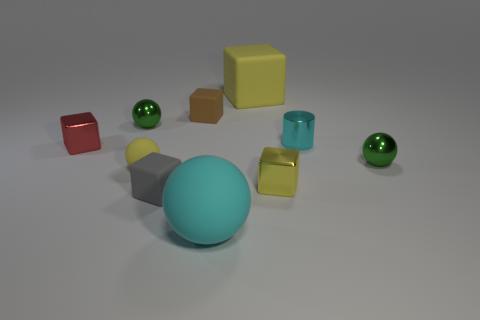What number of things are big yellow balls or yellow blocks?
Give a very brief answer. 2. Is the cyan rubber object the same shape as the small brown thing?
Offer a terse response. No. Is there anything else that is made of the same material as the tiny gray block?
Provide a succinct answer. Yes. Do the green metal ball that is right of the tiny brown matte thing and the yellow ball that is left of the cyan ball have the same size?
Ensure brevity in your answer.  Yes. There is a yellow thing that is right of the big rubber ball and in front of the tiny brown rubber cube; what is its material?
Make the answer very short. Metal. Is there any other thing of the same color as the metallic cylinder?
Your answer should be very brief. Yes. Is the number of small matte objects in front of the red block less than the number of tiny things?
Give a very brief answer. Yes. Are there more yellow metallic objects than small blue metallic objects?
Provide a succinct answer. Yes. Are there any small metal blocks that are in front of the small matte cube behind the small metal sphere that is right of the big yellow rubber block?
Your response must be concise. Yes. How many other things are there of the same size as the brown matte object?
Keep it short and to the point. 7. 